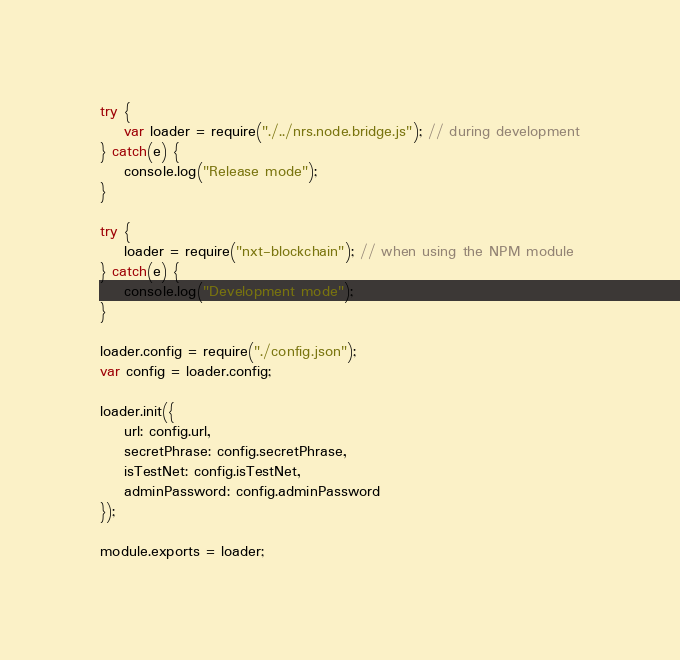Convert code to text. <code><loc_0><loc_0><loc_500><loc_500><_JavaScript_>try {
    var loader = require("./../nrs.node.bridge.js"); // during development
} catch(e) {
    console.log("Release mode");
}

try {
    loader = require("nxt-blockchain"); // when using the NPM module
} catch(e) {
    console.log("Development mode");
}

loader.config = require("./config.json");
var config = loader.config;

loader.init({
    url: config.url,
    secretPhrase: config.secretPhrase,
    isTestNet: config.isTestNet,
    adminPassword: config.adminPassword
});

module.exports = loader;</code> 